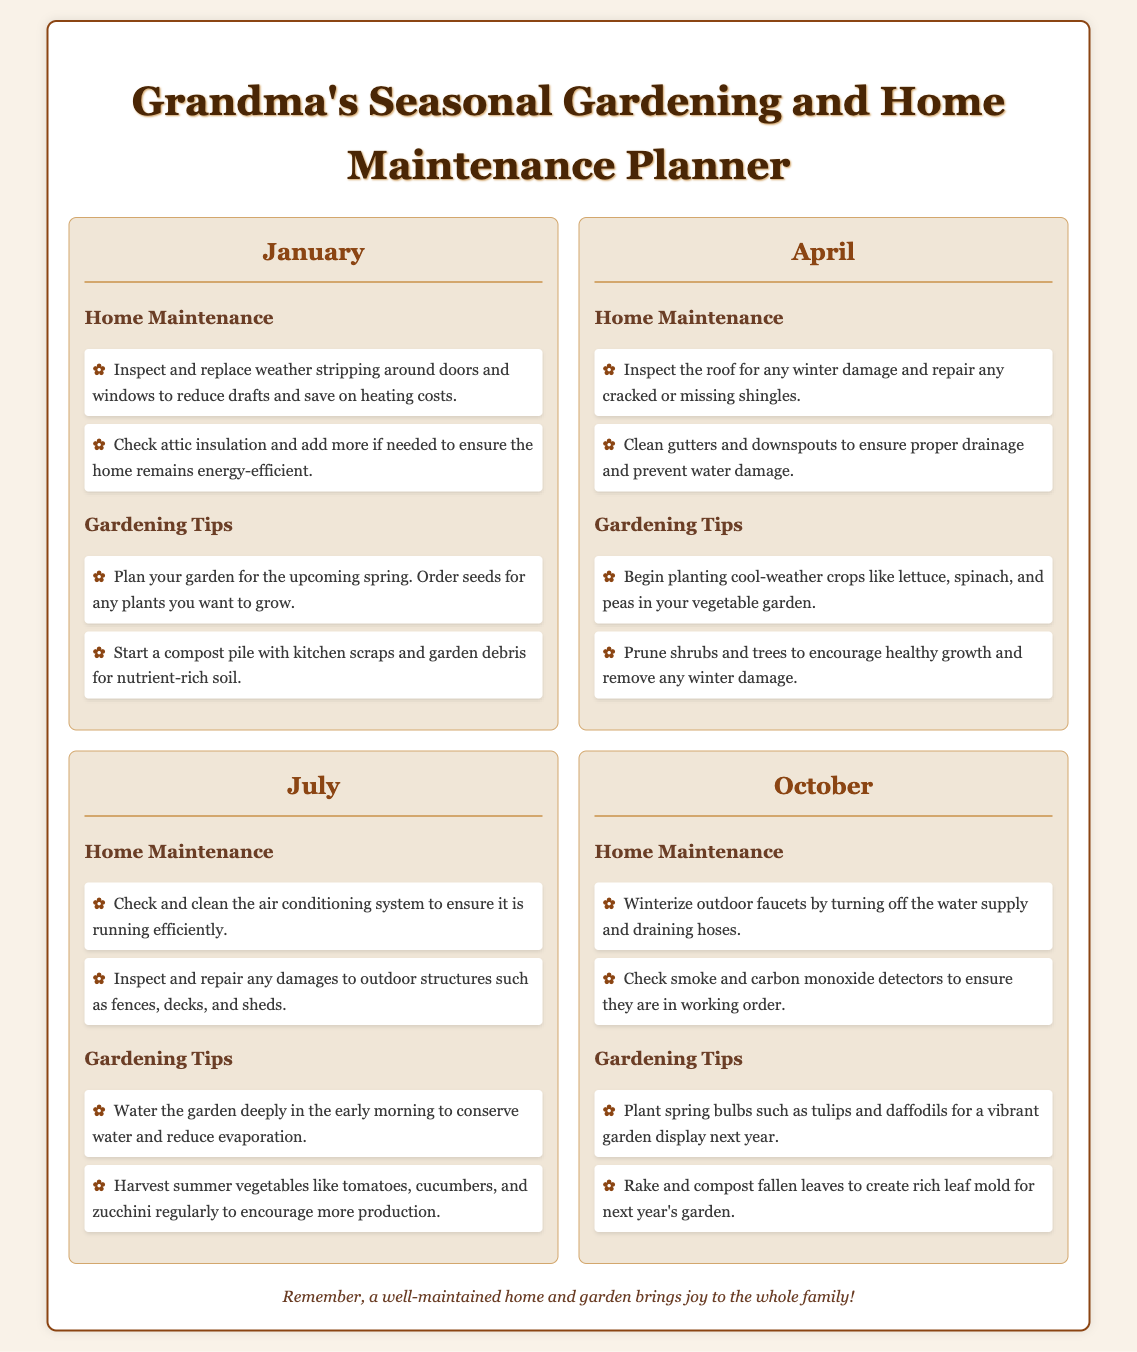What is the main title of the document? The main title appears at the top of the document and encapsulates its focus on gardening and home maintenance.
Answer: Grandma's Seasonal Gardening and Home Maintenance Planner Which month includes tips for planting spring bulbs? The section titled "Gardening Tips" provides specific seasonal guidance, and it outlines the activities for each month.
Answer: October What should you inspect in January to reduce drafts? The home maintenance section for January outlines tasks to ensure home comfort and efficiency.
Answer: Weather stripping How many cool-weather crops are suggested for planting in April? The gardening tips mention specific crops that can be planted during the month of April.
Answer: Two In which month do you need to check smoke detectors? The home maintenance tips detail essential safety checks related to home systems and detectors.
Answer: October What gardening activity is suggested for July? The gardening tips provide time-sensitive tasks for maintaining the garden during the summer months.
Answer: Watering Which item should be added to the compost pile in January? The gardening tips for January suggest starting a compost pile, indicating materials for ideal soil.
Answer: Kitchen scraps What structure should be inspected in July? The home maintenance section identifies areas that require regular upkeep, particularly during the warm months.
Answer: Outdoor structures When is the best time to water the garden according to the July tips? The gardening tips provide specific recommendations for effective watering practices.
Answer: Early morning 